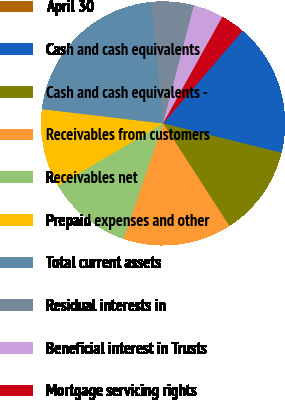Convert chart. <chart><loc_0><loc_0><loc_500><loc_500><pie_chart><fcel>April 30<fcel>Cash and cash equivalents<fcel>Cash and cash equivalents -<fcel>Receivables from customers<fcel>Receivables net<fcel>Prepaid expenses and other<fcel>Total current assets<fcel>Residual interests in<fcel>Beneficial interest in Trusts<fcel>Mortgage servicing rights<nl><fcel>0.0%<fcel>17.6%<fcel>12.0%<fcel>14.4%<fcel>11.2%<fcel>10.4%<fcel>21.6%<fcel>5.6%<fcel>4.0%<fcel>3.2%<nl></chart> 